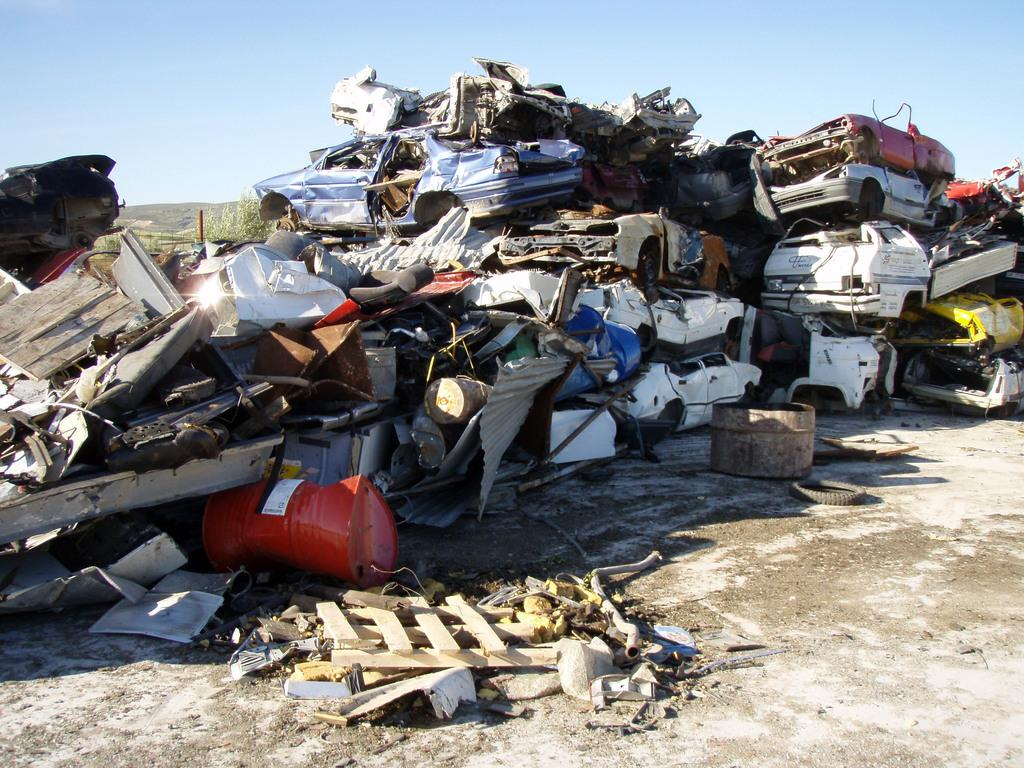What is the main subject in the image? The main subject in the image is a surface. What is on the surface? There is a scrap of cars and iron things on the surface. What can be seen in the background of the image? There is a sky visible in the background of the image. How many people are crying while wearing underwear in the image? There are no people or underwear present in the image; it features a surface with a scrap of cars and iron things. 